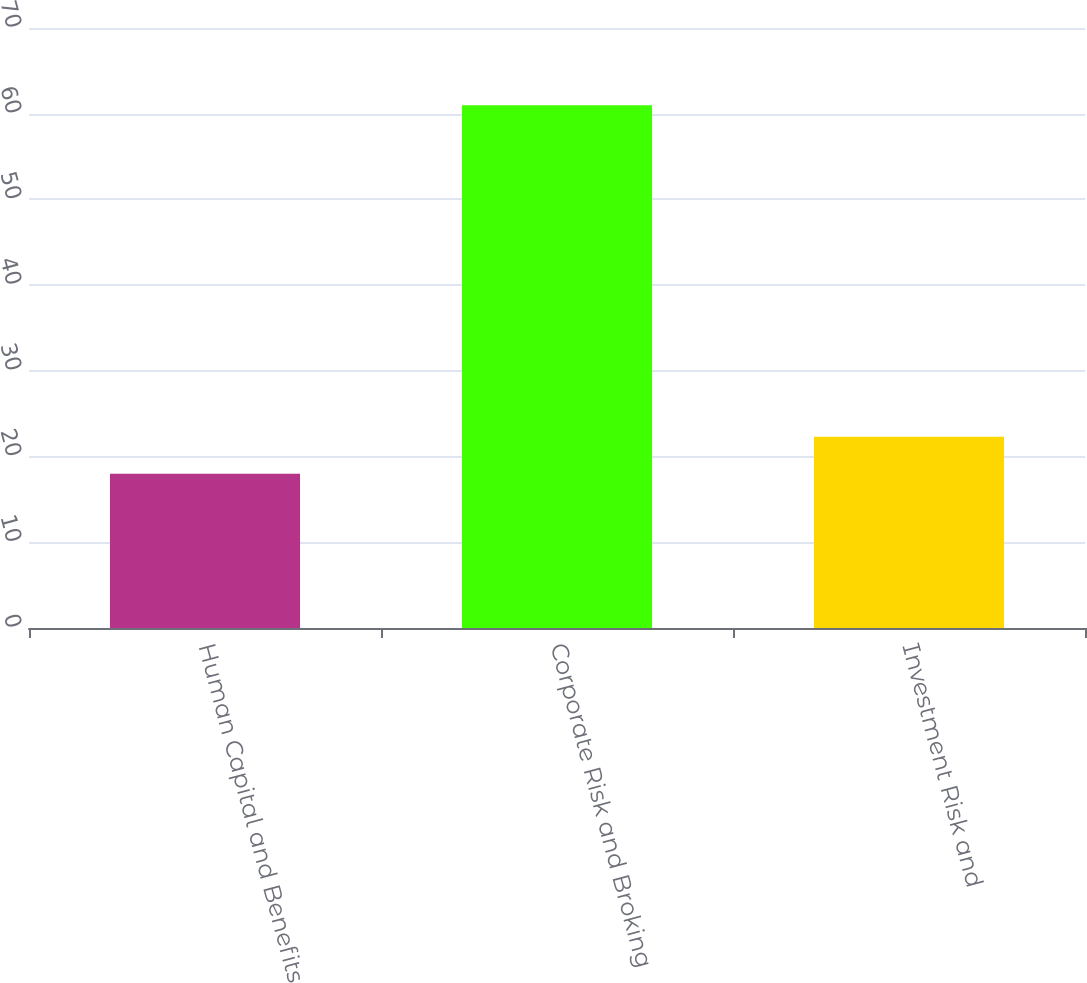<chart> <loc_0><loc_0><loc_500><loc_500><bar_chart><fcel>Human Capital and Benefits<fcel>Corporate Risk and Broking<fcel>Investment Risk and<nl><fcel>18<fcel>61<fcel>22.3<nl></chart> 